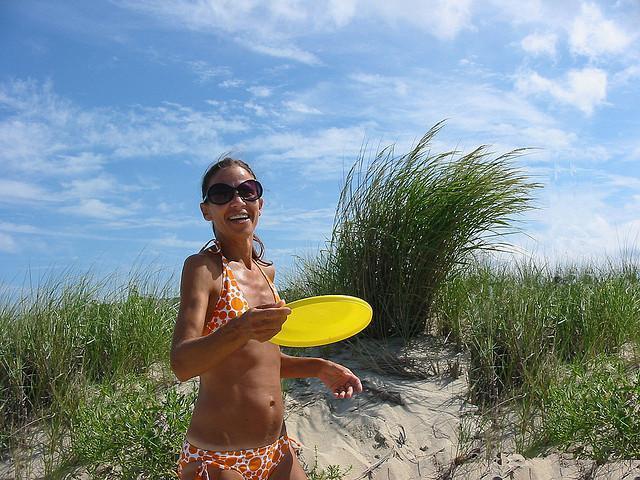How many yellow umbrellas are there?
Give a very brief answer. 0. 